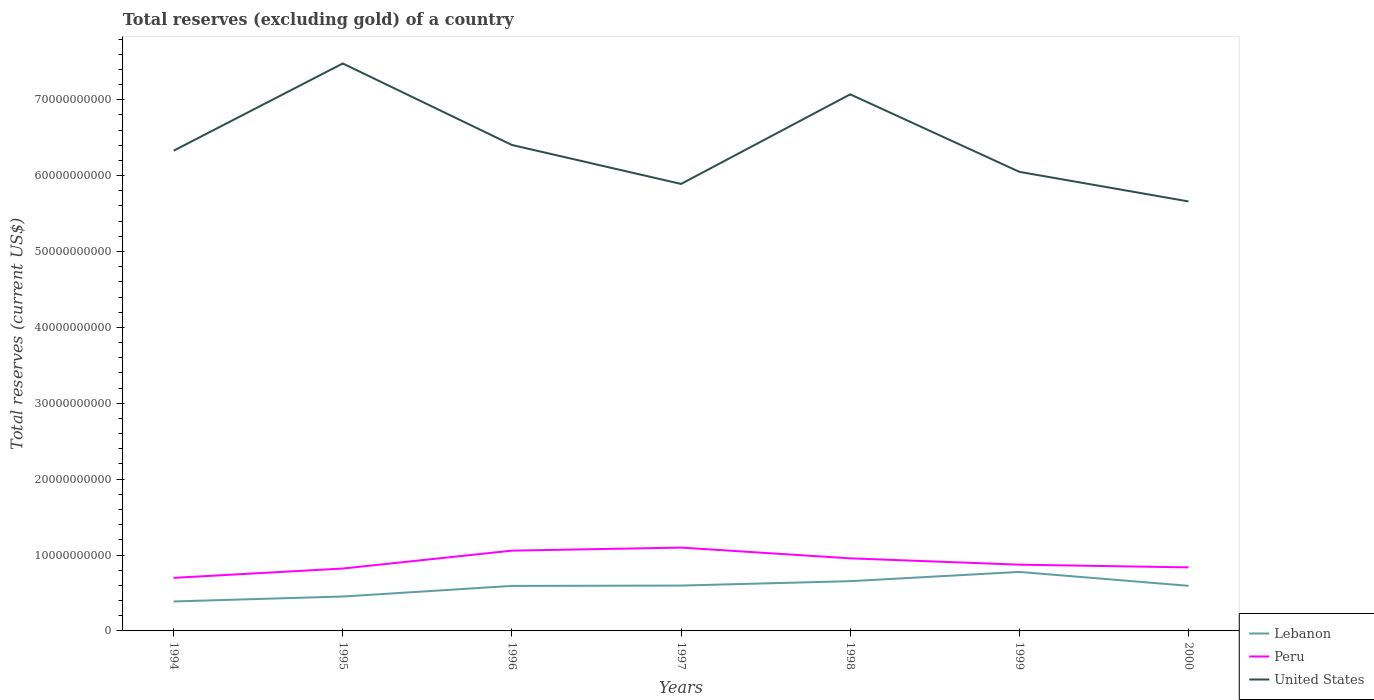How many different coloured lines are there?
Make the answer very short. 3. Is the number of lines equal to the number of legend labels?
Keep it short and to the point. Yes. Across all years, what is the maximum total reserves (excluding gold) in Lebanon?
Keep it short and to the point. 3.88e+09. What is the total total reserves (excluding gold) in Lebanon in the graph?
Keep it short and to the point. -1.40e+09. What is the difference between the highest and the second highest total reserves (excluding gold) in United States?
Provide a short and direct response. 1.82e+1. How many lines are there?
Give a very brief answer. 3. How many years are there in the graph?
Provide a short and direct response. 7. Are the values on the major ticks of Y-axis written in scientific E-notation?
Ensure brevity in your answer.  No. Does the graph contain grids?
Make the answer very short. No. Where does the legend appear in the graph?
Your answer should be compact. Bottom right. How are the legend labels stacked?
Ensure brevity in your answer.  Vertical. What is the title of the graph?
Offer a very short reply. Total reserves (excluding gold) of a country. What is the label or title of the Y-axis?
Offer a terse response. Total reserves (current US$). What is the Total reserves (current US$) of Lebanon in 1994?
Offer a very short reply. 3.88e+09. What is the Total reserves (current US$) in Peru in 1994?
Your answer should be compact. 6.99e+09. What is the Total reserves (current US$) of United States in 1994?
Give a very brief answer. 6.33e+1. What is the Total reserves (current US$) of Lebanon in 1995?
Offer a terse response. 4.53e+09. What is the Total reserves (current US$) in Peru in 1995?
Give a very brief answer. 8.22e+09. What is the Total reserves (current US$) of United States in 1995?
Give a very brief answer. 7.48e+1. What is the Total reserves (current US$) of Lebanon in 1996?
Your answer should be compact. 5.93e+09. What is the Total reserves (current US$) of Peru in 1996?
Offer a very short reply. 1.06e+1. What is the Total reserves (current US$) of United States in 1996?
Provide a short and direct response. 6.40e+1. What is the Total reserves (current US$) of Lebanon in 1997?
Make the answer very short. 5.98e+09. What is the Total reserves (current US$) of Peru in 1997?
Offer a very short reply. 1.10e+1. What is the Total reserves (current US$) in United States in 1997?
Your answer should be compact. 5.89e+1. What is the Total reserves (current US$) of Lebanon in 1998?
Keep it short and to the point. 6.56e+09. What is the Total reserves (current US$) in Peru in 1998?
Keep it short and to the point. 9.57e+09. What is the Total reserves (current US$) of United States in 1998?
Your response must be concise. 7.07e+1. What is the Total reserves (current US$) of Lebanon in 1999?
Make the answer very short. 7.78e+09. What is the Total reserves (current US$) in Peru in 1999?
Offer a very short reply. 8.73e+09. What is the Total reserves (current US$) in United States in 1999?
Offer a very short reply. 6.05e+1. What is the Total reserves (current US$) in Lebanon in 2000?
Your answer should be compact. 5.94e+09. What is the Total reserves (current US$) in Peru in 2000?
Your response must be concise. 8.37e+09. What is the Total reserves (current US$) of United States in 2000?
Your response must be concise. 5.66e+1. Across all years, what is the maximum Total reserves (current US$) of Lebanon?
Your answer should be compact. 7.78e+09. Across all years, what is the maximum Total reserves (current US$) of Peru?
Keep it short and to the point. 1.10e+1. Across all years, what is the maximum Total reserves (current US$) of United States?
Provide a succinct answer. 7.48e+1. Across all years, what is the minimum Total reserves (current US$) in Lebanon?
Keep it short and to the point. 3.88e+09. Across all years, what is the minimum Total reserves (current US$) in Peru?
Provide a short and direct response. 6.99e+09. Across all years, what is the minimum Total reserves (current US$) in United States?
Your response must be concise. 5.66e+1. What is the total Total reserves (current US$) in Lebanon in the graph?
Your answer should be very brief. 4.06e+1. What is the total Total reserves (current US$) of Peru in the graph?
Provide a short and direct response. 6.34e+1. What is the total Total reserves (current US$) of United States in the graph?
Provide a short and direct response. 4.49e+11. What is the difference between the Total reserves (current US$) in Lebanon in 1994 and that in 1995?
Offer a terse response. -6.49e+08. What is the difference between the Total reserves (current US$) of Peru in 1994 and that in 1995?
Give a very brief answer. -1.23e+09. What is the difference between the Total reserves (current US$) in United States in 1994 and that in 1995?
Make the answer very short. -1.15e+1. What is the difference between the Total reserves (current US$) of Lebanon in 1994 and that in 1996?
Your answer should be compact. -2.05e+09. What is the difference between the Total reserves (current US$) of Peru in 1994 and that in 1996?
Your answer should be very brief. -3.59e+09. What is the difference between the Total reserves (current US$) of United States in 1994 and that in 1996?
Offer a very short reply. -7.57e+08. What is the difference between the Total reserves (current US$) in Lebanon in 1994 and that in 1997?
Your answer should be compact. -2.09e+09. What is the difference between the Total reserves (current US$) in Peru in 1994 and that in 1997?
Offer a terse response. -3.99e+09. What is the difference between the Total reserves (current US$) of United States in 1994 and that in 1997?
Offer a terse response. 4.38e+09. What is the difference between the Total reserves (current US$) of Lebanon in 1994 and that in 1998?
Offer a terse response. -2.67e+09. What is the difference between the Total reserves (current US$) of Peru in 1994 and that in 1998?
Give a very brief answer. -2.57e+09. What is the difference between the Total reserves (current US$) of United States in 1994 and that in 1998?
Your answer should be very brief. -7.43e+09. What is the difference between the Total reserves (current US$) of Lebanon in 1994 and that in 1999?
Your answer should be very brief. -3.89e+09. What is the difference between the Total reserves (current US$) of Peru in 1994 and that in 1999?
Offer a very short reply. -1.74e+09. What is the difference between the Total reserves (current US$) of United States in 1994 and that in 1999?
Keep it short and to the point. 2.78e+09. What is the difference between the Total reserves (current US$) in Lebanon in 1994 and that in 2000?
Keep it short and to the point. -2.06e+09. What is the difference between the Total reserves (current US$) in Peru in 1994 and that in 2000?
Your answer should be compact. -1.38e+09. What is the difference between the Total reserves (current US$) of United States in 1994 and that in 2000?
Keep it short and to the point. 6.68e+09. What is the difference between the Total reserves (current US$) of Lebanon in 1995 and that in 1996?
Your answer should be compact. -1.40e+09. What is the difference between the Total reserves (current US$) in Peru in 1995 and that in 1996?
Make the answer very short. -2.36e+09. What is the difference between the Total reserves (current US$) in United States in 1995 and that in 1996?
Your answer should be compact. 1.07e+1. What is the difference between the Total reserves (current US$) in Lebanon in 1995 and that in 1997?
Make the answer very short. -1.44e+09. What is the difference between the Total reserves (current US$) of Peru in 1995 and that in 1997?
Ensure brevity in your answer.  -2.76e+09. What is the difference between the Total reserves (current US$) in United States in 1995 and that in 1997?
Provide a succinct answer. 1.59e+1. What is the difference between the Total reserves (current US$) of Lebanon in 1995 and that in 1998?
Offer a terse response. -2.02e+09. What is the difference between the Total reserves (current US$) of Peru in 1995 and that in 1998?
Offer a very short reply. -1.34e+09. What is the difference between the Total reserves (current US$) in United States in 1995 and that in 1998?
Offer a terse response. 4.07e+09. What is the difference between the Total reserves (current US$) in Lebanon in 1995 and that in 1999?
Make the answer very short. -3.24e+09. What is the difference between the Total reserves (current US$) in Peru in 1995 and that in 1999?
Provide a short and direct response. -5.09e+08. What is the difference between the Total reserves (current US$) in United States in 1995 and that in 1999?
Provide a succinct answer. 1.43e+1. What is the difference between the Total reserves (current US$) of Lebanon in 1995 and that in 2000?
Keep it short and to the point. -1.41e+09. What is the difference between the Total reserves (current US$) of Peru in 1995 and that in 2000?
Ensure brevity in your answer.  -1.52e+08. What is the difference between the Total reserves (current US$) in United States in 1995 and that in 2000?
Keep it short and to the point. 1.82e+1. What is the difference between the Total reserves (current US$) of Lebanon in 1996 and that in 1997?
Give a very brief answer. -4.45e+07. What is the difference between the Total reserves (current US$) in Peru in 1996 and that in 1997?
Provide a succinct answer. -4.04e+08. What is the difference between the Total reserves (current US$) in United States in 1996 and that in 1997?
Offer a terse response. 5.13e+09. What is the difference between the Total reserves (current US$) in Lebanon in 1996 and that in 1998?
Your answer should be very brief. -6.24e+08. What is the difference between the Total reserves (current US$) of Peru in 1996 and that in 1998?
Offer a very short reply. 1.01e+09. What is the difference between the Total reserves (current US$) in United States in 1996 and that in 1998?
Keep it short and to the point. -6.67e+09. What is the difference between the Total reserves (current US$) in Lebanon in 1996 and that in 1999?
Make the answer very short. -1.84e+09. What is the difference between the Total reserves (current US$) of Peru in 1996 and that in 1999?
Provide a succinct answer. 1.85e+09. What is the difference between the Total reserves (current US$) in United States in 1996 and that in 1999?
Your answer should be compact. 3.54e+09. What is the difference between the Total reserves (current US$) of Lebanon in 1996 and that in 2000?
Ensure brevity in your answer.  -1.18e+07. What is the difference between the Total reserves (current US$) of Peru in 1996 and that in 2000?
Make the answer very short. 2.20e+09. What is the difference between the Total reserves (current US$) in United States in 1996 and that in 2000?
Give a very brief answer. 7.44e+09. What is the difference between the Total reserves (current US$) of Lebanon in 1997 and that in 1998?
Ensure brevity in your answer.  -5.80e+08. What is the difference between the Total reserves (current US$) in Peru in 1997 and that in 1998?
Provide a succinct answer. 1.42e+09. What is the difference between the Total reserves (current US$) of United States in 1997 and that in 1998?
Give a very brief answer. -1.18e+1. What is the difference between the Total reserves (current US$) of Lebanon in 1997 and that in 1999?
Ensure brevity in your answer.  -1.80e+09. What is the difference between the Total reserves (current US$) in Peru in 1997 and that in 1999?
Provide a short and direct response. 2.25e+09. What is the difference between the Total reserves (current US$) in United States in 1997 and that in 1999?
Give a very brief answer. -1.59e+09. What is the difference between the Total reserves (current US$) in Lebanon in 1997 and that in 2000?
Your answer should be very brief. 3.27e+07. What is the difference between the Total reserves (current US$) in Peru in 1997 and that in 2000?
Give a very brief answer. 2.61e+09. What is the difference between the Total reserves (current US$) of United States in 1997 and that in 2000?
Offer a terse response. 2.31e+09. What is the difference between the Total reserves (current US$) of Lebanon in 1998 and that in 1999?
Offer a very short reply. -1.22e+09. What is the difference between the Total reserves (current US$) in Peru in 1998 and that in 1999?
Your answer should be compact. 8.35e+08. What is the difference between the Total reserves (current US$) of United States in 1998 and that in 1999?
Your answer should be compact. 1.02e+1. What is the difference between the Total reserves (current US$) of Lebanon in 1998 and that in 2000?
Keep it short and to the point. 6.13e+08. What is the difference between the Total reserves (current US$) in Peru in 1998 and that in 2000?
Keep it short and to the point. 1.19e+09. What is the difference between the Total reserves (current US$) of United States in 1998 and that in 2000?
Make the answer very short. 1.41e+1. What is the difference between the Total reserves (current US$) of Lebanon in 1999 and that in 2000?
Offer a very short reply. 1.83e+09. What is the difference between the Total reserves (current US$) in Peru in 1999 and that in 2000?
Ensure brevity in your answer.  3.56e+08. What is the difference between the Total reserves (current US$) of United States in 1999 and that in 2000?
Your answer should be very brief. 3.90e+09. What is the difference between the Total reserves (current US$) in Lebanon in 1994 and the Total reserves (current US$) in Peru in 1995?
Your response must be concise. -4.34e+09. What is the difference between the Total reserves (current US$) in Lebanon in 1994 and the Total reserves (current US$) in United States in 1995?
Provide a short and direct response. -7.09e+1. What is the difference between the Total reserves (current US$) in Peru in 1994 and the Total reserves (current US$) in United States in 1995?
Make the answer very short. -6.78e+1. What is the difference between the Total reserves (current US$) in Lebanon in 1994 and the Total reserves (current US$) in Peru in 1996?
Provide a succinct answer. -6.69e+09. What is the difference between the Total reserves (current US$) of Lebanon in 1994 and the Total reserves (current US$) of United States in 1996?
Make the answer very short. -6.02e+1. What is the difference between the Total reserves (current US$) of Peru in 1994 and the Total reserves (current US$) of United States in 1996?
Your answer should be compact. -5.70e+1. What is the difference between the Total reserves (current US$) in Lebanon in 1994 and the Total reserves (current US$) in Peru in 1997?
Ensure brevity in your answer.  -7.10e+09. What is the difference between the Total reserves (current US$) of Lebanon in 1994 and the Total reserves (current US$) of United States in 1997?
Your answer should be very brief. -5.50e+1. What is the difference between the Total reserves (current US$) of Peru in 1994 and the Total reserves (current US$) of United States in 1997?
Give a very brief answer. -5.19e+1. What is the difference between the Total reserves (current US$) of Lebanon in 1994 and the Total reserves (current US$) of Peru in 1998?
Keep it short and to the point. -5.68e+09. What is the difference between the Total reserves (current US$) in Lebanon in 1994 and the Total reserves (current US$) in United States in 1998?
Give a very brief answer. -6.68e+1. What is the difference between the Total reserves (current US$) in Peru in 1994 and the Total reserves (current US$) in United States in 1998?
Your answer should be very brief. -6.37e+1. What is the difference between the Total reserves (current US$) in Lebanon in 1994 and the Total reserves (current US$) in Peru in 1999?
Your answer should be very brief. -4.85e+09. What is the difference between the Total reserves (current US$) of Lebanon in 1994 and the Total reserves (current US$) of United States in 1999?
Give a very brief answer. -5.66e+1. What is the difference between the Total reserves (current US$) of Peru in 1994 and the Total reserves (current US$) of United States in 1999?
Provide a short and direct response. -5.35e+1. What is the difference between the Total reserves (current US$) in Lebanon in 1994 and the Total reserves (current US$) in Peru in 2000?
Provide a short and direct response. -4.49e+09. What is the difference between the Total reserves (current US$) of Lebanon in 1994 and the Total reserves (current US$) of United States in 2000?
Ensure brevity in your answer.  -5.27e+1. What is the difference between the Total reserves (current US$) of Peru in 1994 and the Total reserves (current US$) of United States in 2000?
Ensure brevity in your answer.  -4.96e+1. What is the difference between the Total reserves (current US$) in Lebanon in 1995 and the Total reserves (current US$) in Peru in 1996?
Your answer should be very brief. -6.04e+09. What is the difference between the Total reserves (current US$) in Lebanon in 1995 and the Total reserves (current US$) in United States in 1996?
Ensure brevity in your answer.  -5.95e+1. What is the difference between the Total reserves (current US$) in Peru in 1995 and the Total reserves (current US$) in United States in 1996?
Offer a very short reply. -5.58e+1. What is the difference between the Total reserves (current US$) in Lebanon in 1995 and the Total reserves (current US$) in Peru in 1997?
Your answer should be very brief. -6.45e+09. What is the difference between the Total reserves (current US$) in Lebanon in 1995 and the Total reserves (current US$) in United States in 1997?
Provide a succinct answer. -5.44e+1. What is the difference between the Total reserves (current US$) of Peru in 1995 and the Total reserves (current US$) of United States in 1997?
Make the answer very short. -5.07e+1. What is the difference between the Total reserves (current US$) of Lebanon in 1995 and the Total reserves (current US$) of Peru in 1998?
Keep it short and to the point. -5.03e+09. What is the difference between the Total reserves (current US$) in Lebanon in 1995 and the Total reserves (current US$) in United States in 1998?
Offer a terse response. -6.62e+1. What is the difference between the Total reserves (current US$) of Peru in 1995 and the Total reserves (current US$) of United States in 1998?
Your answer should be compact. -6.25e+1. What is the difference between the Total reserves (current US$) in Lebanon in 1995 and the Total reserves (current US$) in Peru in 1999?
Offer a very short reply. -4.20e+09. What is the difference between the Total reserves (current US$) in Lebanon in 1995 and the Total reserves (current US$) in United States in 1999?
Ensure brevity in your answer.  -5.60e+1. What is the difference between the Total reserves (current US$) in Peru in 1995 and the Total reserves (current US$) in United States in 1999?
Ensure brevity in your answer.  -5.23e+1. What is the difference between the Total reserves (current US$) in Lebanon in 1995 and the Total reserves (current US$) in Peru in 2000?
Your response must be concise. -3.84e+09. What is the difference between the Total reserves (current US$) of Lebanon in 1995 and the Total reserves (current US$) of United States in 2000?
Keep it short and to the point. -5.21e+1. What is the difference between the Total reserves (current US$) in Peru in 1995 and the Total reserves (current US$) in United States in 2000?
Your answer should be compact. -4.84e+1. What is the difference between the Total reserves (current US$) in Lebanon in 1996 and the Total reserves (current US$) in Peru in 1997?
Keep it short and to the point. -5.05e+09. What is the difference between the Total reserves (current US$) in Lebanon in 1996 and the Total reserves (current US$) in United States in 1997?
Your answer should be compact. -5.30e+1. What is the difference between the Total reserves (current US$) in Peru in 1996 and the Total reserves (current US$) in United States in 1997?
Your answer should be very brief. -4.83e+1. What is the difference between the Total reserves (current US$) of Lebanon in 1996 and the Total reserves (current US$) of Peru in 1998?
Your answer should be compact. -3.63e+09. What is the difference between the Total reserves (current US$) in Lebanon in 1996 and the Total reserves (current US$) in United States in 1998?
Make the answer very short. -6.48e+1. What is the difference between the Total reserves (current US$) in Peru in 1996 and the Total reserves (current US$) in United States in 1998?
Provide a short and direct response. -6.01e+1. What is the difference between the Total reserves (current US$) in Lebanon in 1996 and the Total reserves (current US$) in Peru in 1999?
Offer a very short reply. -2.80e+09. What is the difference between the Total reserves (current US$) of Lebanon in 1996 and the Total reserves (current US$) of United States in 1999?
Provide a short and direct response. -5.46e+1. What is the difference between the Total reserves (current US$) in Peru in 1996 and the Total reserves (current US$) in United States in 1999?
Make the answer very short. -4.99e+1. What is the difference between the Total reserves (current US$) in Lebanon in 1996 and the Total reserves (current US$) in Peru in 2000?
Provide a succinct answer. -2.44e+09. What is the difference between the Total reserves (current US$) in Lebanon in 1996 and the Total reserves (current US$) in United States in 2000?
Offer a very short reply. -5.07e+1. What is the difference between the Total reserves (current US$) of Peru in 1996 and the Total reserves (current US$) of United States in 2000?
Offer a very short reply. -4.60e+1. What is the difference between the Total reserves (current US$) in Lebanon in 1997 and the Total reserves (current US$) in Peru in 1998?
Offer a very short reply. -3.59e+09. What is the difference between the Total reserves (current US$) in Lebanon in 1997 and the Total reserves (current US$) in United States in 1998?
Give a very brief answer. -6.47e+1. What is the difference between the Total reserves (current US$) of Peru in 1997 and the Total reserves (current US$) of United States in 1998?
Offer a very short reply. -5.97e+1. What is the difference between the Total reserves (current US$) in Lebanon in 1997 and the Total reserves (current US$) in Peru in 1999?
Your answer should be compact. -2.75e+09. What is the difference between the Total reserves (current US$) in Lebanon in 1997 and the Total reserves (current US$) in United States in 1999?
Offer a very short reply. -5.45e+1. What is the difference between the Total reserves (current US$) in Peru in 1997 and the Total reserves (current US$) in United States in 1999?
Offer a very short reply. -4.95e+1. What is the difference between the Total reserves (current US$) of Lebanon in 1997 and the Total reserves (current US$) of Peru in 2000?
Offer a terse response. -2.40e+09. What is the difference between the Total reserves (current US$) in Lebanon in 1997 and the Total reserves (current US$) in United States in 2000?
Your response must be concise. -5.06e+1. What is the difference between the Total reserves (current US$) in Peru in 1997 and the Total reserves (current US$) in United States in 2000?
Keep it short and to the point. -4.56e+1. What is the difference between the Total reserves (current US$) of Lebanon in 1998 and the Total reserves (current US$) of Peru in 1999?
Your response must be concise. -2.17e+09. What is the difference between the Total reserves (current US$) in Lebanon in 1998 and the Total reserves (current US$) in United States in 1999?
Your answer should be compact. -5.39e+1. What is the difference between the Total reserves (current US$) of Peru in 1998 and the Total reserves (current US$) of United States in 1999?
Ensure brevity in your answer.  -5.09e+1. What is the difference between the Total reserves (current US$) of Lebanon in 1998 and the Total reserves (current US$) of Peru in 2000?
Make the answer very short. -1.82e+09. What is the difference between the Total reserves (current US$) in Lebanon in 1998 and the Total reserves (current US$) in United States in 2000?
Your answer should be very brief. -5.00e+1. What is the difference between the Total reserves (current US$) of Peru in 1998 and the Total reserves (current US$) of United States in 2000?
Make the answer very short. -4.70e+1. What is the difference between the Total reserves (current US$) of Lebanon in 1999 and the Total reserves (current US$) of Peru in 2000?
Your answer should be compact. -5.98e+08. What is the difference between the Total reserves (current US$) of Lebanon in 1999 and the Total reserves (current US$) of United States in 2000?
Provide a succinct answer. -4.88e+1. What is the difference between the Total reserves (current US$) in Peru in 1999 and the Total reserves (current US$) in United States in 2000?
Your response must be concise. -4.79e+1. What is the average Total reserves (current US$) in Lebanon per year?
Offer a terse response. 5.80e+09. What is the average Total reserves (current US$) of Peru per year?
Give a very brief answer. 9.06e+09. What is the average Total reserves (current US$) of United States per year?
Give a very brief answer. 6.41e+1. In the year 1994, what is the difference between the Total reserves (current US$) of Lebanon and Total reserves (current US$) of Peru?
Give a very brief answer. -3.11e+09. In the year 1994, what is the difference between the Total reserves (current US$) of Lebanon and Total reserves (current US$) of United States?
Offer a very short reply. -5.94e+1. In the year 1994, what is the difference between the Total reserves (current US$) of Peru and Total reserves (current US$) of United States?
Provide a succinct answer. -5.63e+1. In the year 1995, what is the difference between the Total reserves (current US$) of Lebanon and Total reserves (current US$) of Peru?
Provide a short and direct response. -3.69e+09. In the year 1995, what is the difference between the Total reserves (current US$) of Lebanon and Total reserves (current US$) of United States?
Offer a very short reply. -7.02e+1. In the year 1995, what is the difference between the Total reserves (current US$) of Peru and Total reserves (current US$) of United States?
Your answer should be compact. -6.66e+1. In the year 1996, what is the difference between the Total reserves (current US$) in Lebanon and Total reserves (current US$) in Peru?
Make the answer very short. -4.65e+09. In the year 1996, what is the difference between the Total reserves (current US$) in Lebanon and Total reserves (current US$) in United States?
Provide a short and direct response. -5.81e+1. In the year 1996, what is the difference between the Total reserves (current US$) in Peru and Total reserves (current US$) in United States?
Make the answer very short. -5.35e+1. In the year 1997, what is the difference between the Total reserves (current US$) in Lebanon and Total reserves (current US$) in Peru?
Offer a terse response. -5.01e+09. In the year 1997, what is the difference between the Total reserves (current US$) in Lebanon and Total reserves (current US$) in United States?
Provide a succinct answer. -5.29e+1. In the year 1997, what is the difference between the Total reserves (current US$) in Peru and Total reserves (current US$) in United States?
Ensure brevity in your answer.  -4.79e+1. In the year 1998, what is the difference between the Total reserves (current US$) in Lebanon and Total reserves (current US$) in Peru?
Offer a very short reply. -3.01e+09. In the year 1998, what is the difference between the Total reserves (current US$) of Lebanon and Total reserves (current US$) of United States?
Give a very brief answer. -6.42e+1. In the year 1998, what is the difference between the Total reserves (current US$) of Peru and Total reserves (current US$) of United States?
Your response must be concise. -6.11e+1. In the year 1999, what is the difference between the Total reserves (current US$) in Lebanon and Total reserves (current US$) in Peru?
Offer a terse response. -9.55e+08. In the year 1999, what is the difference between the Total reserves (current US$) in Lebanon and Total reserves (current US$) in United States?
Make the answer very short. -5.27e+1. In the year 1999, what is the difference between the Total reserves (current US$) of Peru and Total reserves (current US$) of United States?
Provide a short and direct response. -5.18e+1. In the year 2000, what is the difference between the Total reserves (current US$) in Lebanon and Total reserves (current US$) in Peru?
Keep it short and to the point. -2.43e+09. In the year 2000, what is the difference between the Total reserves (current US$) of Lebanon and Total reserves (current US$) of United States?
Provide a short and direct response. -5.07e+1. In the year 2000, what is the difference between the Total reserves (current US$) of Peru and Total reserves (current US$) of United States?
Make the answer very short. -4.82e+1. What is the ratio of the Total reserves (current US$) in Lebanon in 1994 to that in 1995?
Ensure brevity in your answer.  0.86. What is the ratio of the Total reserves (current US$) in Peru in 1994 to that in 1995?
Keep it short and to the point. 0.85. What is the ratio of the Total reserves (current US$) of United States in 1994 to that in 1995?
Provide a succinct answer. 0.85. What is the ratio of the Total reserves (current US$) of Lebanon in 1994 to that in 1996?
Give a very brief answer. 0.65. What is the ratio of the Total reserves (current US$) of Peru in 1994 to that in 1996?
Make the answer very short. 0.66. What is the ratio of the Total reserves (current US$) in United States in 1994 to that in 1996?
Your response must be concise. 0.99. What is the ratio of the Total reserves (current US$) in Lebanon in 1994 to that in 1997?
Keep it short and to the point. 0.65. What is the ratio of the Total reserves (current US$) of Peru in 1994 to that in 1997?
Make the answer very short. 0.64. What is the ratio of the Total reserves (current US$) in United States in 1994 to that in 1997?
Provide a succinct answer. 1.07. What is the ratio of the Total reserves (current US$) in Lebanon in 1994 to that in 1998?
Provide a short and direct response. 0.59. What is the ratio of the Total reserves (current US$) in Peru in 1994 to that in 1998?
Offer a terse response. 0.73. What is the ratio of the Total reserves (current US$) of United States in 1994 to that in 1998?
Provide a succinct answer. 0.89. What is the ratio of the Total reserves (current US$) of Lebanon in 1994 to that in 1999?
Offer a terse response. 0.5. What is the ratio of the Total reserves (current US$) in Peru in 1994 to that in 1999?
Your response must be concise. 0.8. What is the ratio of the Total reserves (current US$) in United States in 1994 to that in 1999?
Offer a terse response. 1.05. What is the ratio of the Total reserves (current US$) of Lebanon in 1994 to that in 2000?
Offer a terse response. 0.65. What is the ratio of the Total reserves (current US$) in Peru in 1994 to that in 2000?
Your answer should be very brief. 0.83. What is the ratio of the Total reserves (current US$) of United States in 1994 to that in 2000?
Your answer should be very brief. 1.12. What is the ratio of the Total reserves (current US$) of Lebanon in 1995 to that in 1996?
Ensure brevity in your answer.  0.76. What is the ratio of the Total reserves (current US$) of Peru in 1995 to that in 1996?
Offer a terse response. 0.78. What is the ratio of the Total reserves (current US$) in United States in 1995 to that in 1996?
Give a very brief answer. 1.17. What is the ratio of the Total reserves (current US$) of Lebanon in 1995 to that in 1997?
Offer a terse response. 0.76. What is the ratio of the Total reserves (current US$) in Peru in 1995 to that in 1997?
Make the answer very short. 0.75. What is the ratio of the Total reserves (current US$) in United States in 1995 to that in 1997?
Make the answer very short. 1.27. What is the ratio of the Total reserves (current US$) in Lebanon in 1995 to that in 1998?
Give a very brief answer. 0.69. What is the ratio of the Total reserves (current US$) in Peru in 1995 to that in 1998?
Keep it short and to the point. 0.86. What is the ratio of the Total reserves (current US$) of United States in 1995 to that in 1998?
Ensure brevity in your answer.  1.06. What is the ratio of the Total reserves (current US$) of Lebanon in 1995 to that in 1999?
Make the answer very short. 0.58. What is the ratio of the Total reserves (current US$) of Peru in 1995 to that in 1999?
Provide a short and direct response. 0.94. What is the ratio of the Total reserves (current US$) of United States in 1995 to that in 1999?
Ensure brevity in your answer.  1.24. What is the ratio of the Total reserves (current US$) in Lebanon in 1995 to that in 2000?
Offer a very short reply. 0.76. What is the ratio of the Total reserves (current US$) of Peru in 1995 to that in 2000?
Offer a terse response. 0.98. What is the ratio of the Total reserves (current US$) of United States in 1995 to that in 2000?
Offer a very short reply. 1.32. What is the ratio of the Total reserves (current US$) of Peru in 1996 to that in 1997?
Provide a short and direct response. 0.96. What is the ratio of the Total reserves (current US$) of United States in 1996 to that in 1997?
Ensure brevity in your answer.  1.09. What is the ratio of the Total reserves (current US$) of Lebanon in 1996 to that in 1998?
Keep it short and to the point. 0.9. What is the ratio of the Total reserves (current US$) in Peru in 1996 to that in 1998?
Provide a succinct answer. 1.11. What is the ratio of the Total reserves (current US$) in United States in 1996 to that in 1998?
Give a very brief answer. 0.91. What is the ratio of the Total reserves (current US$) in Lebanon in 1996 to that in 1999?
Give a very brief answer. 0.76. What is the ratio of the Total reserves (current US$) in Peru in 1996 to that in 1999?
Make the answer very short. 1.21. What is the ratio of the Total reserves (current US$) in United States in 1996 to that in 1999?
Provide a short and direct response. 1.06. What is the ratio of the Total reserves (current US$) of Peru in 1996 to that in 2000?
Offer a terse response. 1.26. What is the ratio of the Total reserves (current US$) in United States in 1996 to that in 2000?
Ensure brevity in your answer.  1.13. What is the ratio of the Total reserves (current US$) of Lebanon in 1997 to that in 1998?
Your response must be concise. 0.91. What is the ratio of the Total reserves (current US$) in Peru in 1997 to that in 1998?
Provide a short and direct response. 1.15. What is the ratio of the Total reserves (current US$) in United States in 1997 to that in 1998?
Offer a terse response. 0.83. What is the ratio of the Total reserves (current US$) of Lebanon in 1997 to that in 1999?
Offer a terse response. 0.77. What is the ratio of the Total reserves (current US$) in Peru in 1997 to that in 1999?
Keep it short and to the point. 1.26. What is the ratio of the Total reserves (current US$) of United States in 1997 to that in 1999?
Keep it short and to the point. 0.97. What is the ratio of the Total reserves (current US$) in Peru in 1997 to that in 2000?
Your response must be concise. 1.31. What is the ratio of the Total reserves (current US$) of United States in 1997 to that in 2000?
Your answer should be very brief. 1.04. What is the ratio of the Total reserves (current US$) of Lebanon in 1998 to that in 1999?
Offer a terse response. 0.84. What is the ratio of the Total reserves (current US$) of Peru in 1998 to that in 1999?
Keep it short and to the point. 1.1. What is the ratio of the Total reserves (current US$) in United States in 1998 to that in 1999?
Give a very brief answer. 1.17. What is the ratio of the Total reserves (current US$) of Lebanon in 1998 to that in 2000?
Your answer should be compact. 1.1. What is the ratio of the Total reserves (current US$) in Peru in 1998 to that in 2000?
Offer a very short reply. 1.14. What is the ratio of the Total reserves (current US$) in United States in 1998 to that in 2000?
Offer a very short reply. 1.25. What is the ratio of the Total reserves (current US$) of Lebanon in 1999 to that in 2000?
Your response must be concise. 1.31. What is the ratio of the Total reserves (current US$) in Peru in 1999 to that in 2000?
Offer a terse response. 1.04. What is the ratio of the Total reserves (current US$) of United States in 1999 to that in 2000?
Offer a very short reply. 1.07. What is the difference between the highest and the second highest Total reserves (current US$) of Lebanon?
Offer a very short reply. 1.22e+09. What is the difference between the highest and the second highest Total reserves (current US$) in Peru?
Offer a terse response. 4.04e+08. What is the difference between the highest and the second highest Total reserves (current US$) in United States?
Keep it short and to the point. 4.07e+09. What is the difference between the highest and the lowest Total reserves (current US$) in Lebanon?
Give a very brief answer. 3.89e+09. What is the difference between the highest and the lowest Total reserves (current US$) in Peru?
Provide a succinct answer. 3.99e+09. What is the difference between the highest and the lowest Total reserves (current US$) in United States?
Offer a terse response. 1.82e+1. 